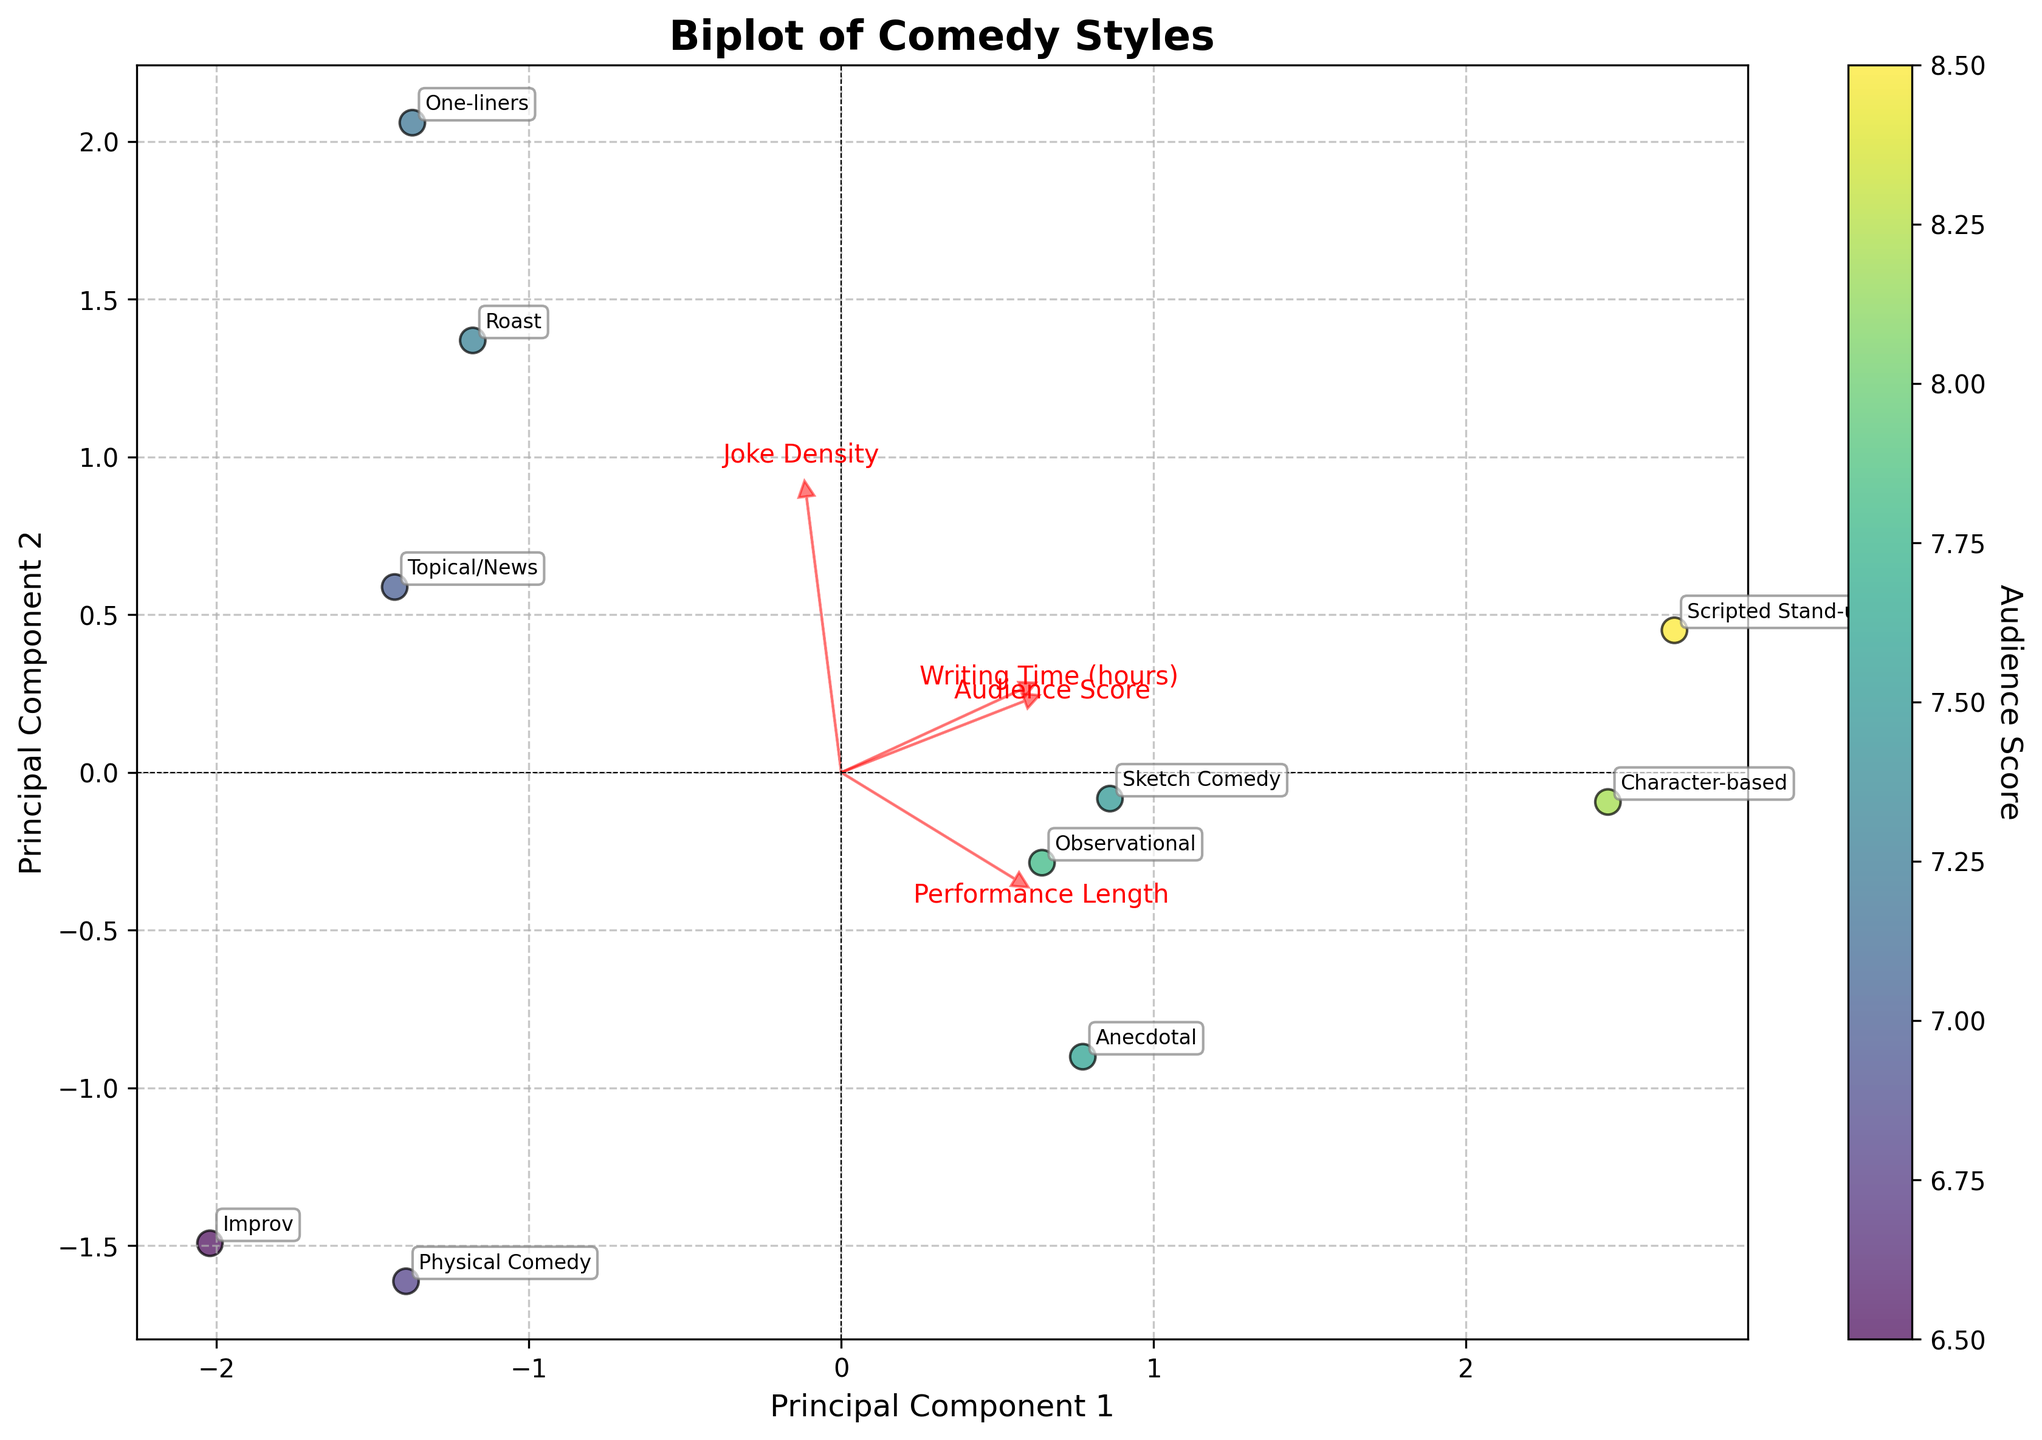What is the title of the plot? The title is usually at the top of the plot, often in a larger or bolder font. In this case, the title is 'Biplot of Comedy Styles'.
Answer: Biplot of Comedy Styles How many comedy styles are represented in the plot? Count the labels associated with different points scattered across the plot. Each label corresponds to a comedy style. There are 10 labels, so there are 10 comedy styles.
Answer: 10 Which comedy style has the highest Audience Score? The color of the points represents the Audience Score. Identify the point with the richest (likely yellow or yellow-green) color. According to the data, the 'Scripted Stand-up' has the highest Audience Score.
Answer: Scripted Stand-up What combination of features is indicated by the longest red arrow? Red arrows point from the origin to show the direction and magnitude of principal components. The longest arrow represents the feature that contributes the most variance. By checking the biplot, 'Writing Time (hours)' has the longest arrow.
Answer: Writing Time (hours) Which two comedy styles are closest to each other in the biplot? Observe the distances between the points representing different comedy styles. 'Roast' and 'One-liners' appear to be closest to one another.
Answer: Roast and One-liners What is the direction associated with 'Performance Length'? The red arrow for 'Performance Length' points in a specific direction, showing how this feature aligns with the principal components. It points to the upper right quadrant.
Answer: Upper right quadrant Is comedy style 'Improv' associated with higher or lower Writing Time and how is it positioned relative to 'Writing Time (hours)'? Find the 'Improv' label and see its position relative to the 'Writing Time (hours)' arrow. 'Improv' is far from the 'Writing Time' arrow and closer to the origin, indicating lower writing time.
Answer: Lower writing time How does the Audience Score correlate with the Writing Time feature according to the plot? Look at the overall position of points in relation to the 'Writing Time (hours)' arrow and see how their color gradients change. Points with higher scores (brighter colors) tend to be aligned more closely with the 'Writing Time (hours)' arrow, indicating a positive correlation.
Answer: Positively correlated Which comedy style has the lowest joke density based on the biplot? Arrows in the biplot can help determine which points are aligned with features. The 'Physical Comedy' label lies closer to the low end of the 'Joke Density' arrow.
Answer: Physical Comedy What two features seem to be inversely related based on the directions of their arrows? Examine the angles between the red arrows representing features. Features with arrows pointing in nearly opposite directions imply an inverse relationship. 'Joke Density' and 'Performance Length' arrows point in roughly opposite directions.
Answer: Joke Density and Performance Length 